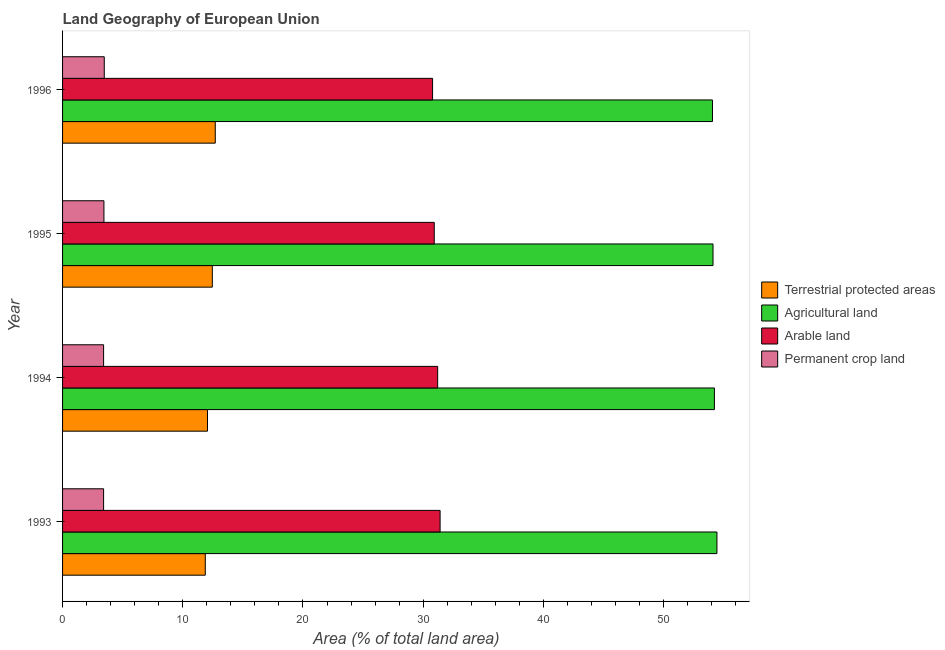Are the number of bars on each tick of the Y-axis equal?
Make the answer very short. Yes. How many bars are there on the 1st tick from the bottom?
Keep it short and to the point. 4. What is the label of the 2nd group of bars from the top?
Your answer should be compact. 1995. In how many cases, is the number of bars for a given year not equal to the number of legend labels?
Your answer should be compact. 0. What is the percentage of area under agricultural land in 1995?
Your answer should be very brief. 54.11. Across all years, what is the maximum percentage of area under agricultural land?
Make the answer very short. 54.44. Across all years, what is the minimum percentage of area under agricultural land?
Your response must be concise. 54.06. In which year was the percentage of land under terrestrial protection minimum?
Your answer should be very brief. 1993. What is the total percentage of area under permanent crop land in the graph?
Provide a succinct answer. 13.74. What is the difference between the percentage of area under agricultural land in 1994 and that in 1996?
Make the answer very short. 0.16. What is the difference between the percentage of area under permanent crop land in 1994 and the percentage of area under arable land in 1995?
Give a very brief answer. -27.51. What is the average percentage of area under arable land per year?
Provide a succinct answer. 31.08. In the year 1996, what is the difference between the percentage of area under permanent crop land and percentage of area under arable land?
Offer a very short reply. -27.31. Is the percentage of area under arable land in 1993 less than that in 1996?
Your answer should be very brief. No. Is the difference between the percentage of area under agricultural land in 1993 and 1996 greater than the difference between the percentage of land under terrestrial protection in 1993 and 1996?
Your response must be concise. Yes. What is the difference between the highest and the second highest percentage of land under terrestrial protection?
Your response must be concise. 0.25. What is the difference between the highest and the lowest percentage of land under terrestrial protection?
Give a very brief answer. 0.83. In how many years, is the percentage of area under permanent crop land greater than the average percentage of area under permanent crop land taken over all years?
Give a very brief answer. 2. Is it the case that in every year, the sum of the percentage of area under arable land and percentage of area under permanent crop land is greater than the sum of percentage of land under terrestrial protection and percentage of area under agricultural land?
Offer a very short reply. Yes. What does the 3rd bar from the top in 1994 represents?
Make the answer very short. Agricultural land. What does the 3rd bar from the bottom in 1996 represents?
Your response must be concise. Arable land. Is it the case that in every year, the sum of the percentage of land under terrestrial protection and percentage of area under agricultural land is greater than the percentage of area under arable land?
Offer a very short reply. Yes. Does the graph contain any zero values?
Ensure brevity in your answer.  No. Where does the legend appear in the graph?
Give a very brief answer. Center right. How many legend labels are there?
Your answer should be compact. 4. How are the legend labels stacked?
Provide a succinct answer. Vertical. What is the title of the graph?
Your response must be concise. Land Geography of European Union. Does "Belgium" appear as one of the legend labels in the graph?
Offer a terse response. No. What is the label or title of the X-axis?
Keep it short and to the point. Area (% of total land area). What is the Area (% of total land area) in Terrestrial protected areas in 1993?
Give a very brief answer. 11.87. What is the Area (% of total land area) of Agricultural land in 1993?
Provide a short and direct response. 54.44. What is the Area (% of total land area) in Arable land in 1993?
Offer a terse response. 31.41. What is the Area (% of total land area) of Permanent crop land in 1993?
Make the answer very short. 3.41. What is the Area (% of total land area) of Terrestrial protected areas in 1994?
Your answer should be compact. 12.06. What is the Area (% of total land area) of Agricultural land in 1994?
Provide a succinct answer. 54.23. What is the Area (% of total land area) of Arable land in 1994?
Provide a succinct answer. 31.2. What is the Area (% of total land area) of Permanent crop land in 1994?
Provide a succinct answer. 3.41. What is the Area (% of total land area) in Terrestrial protected areas in 1995?
Keep it short and to the point. 12.46. What is the Area (% of total land area) in Agricultural land in 1995?
Offer a very short reply. 54.11. What is the Area (% of total land area) of Arable land in 1995?
Your answer should be compact. 30.92. What is the Area (% of total land area) in Permanent crop land in 1995?
Provide a succinct answer. 3.44. What is the Area (% of total land area) in Terrestrial protected areas in 1996?
Your answer should be compact. 12.7. What is the Area (% of total land area) of Agricultural land in 1996?
Your answer should be compact. 54.06. What is the Area (% of total land area) in Arable land in 1996?
Offer a terse response. 30.78. What is the Area (% of total land area) of Permanent crop land in 1996?
Offer a terse response. 3.47. Across all years, what is the maximum Area (% of total land area) in Terrestrial protected areas?
Your answer should be compact. 12.7. Across all years, what is the maximum Area (% of total land area) in Agricultural land?
Your answer should be very brief. 54.44. Across all years, what is the maximum Area (% of total land area) in Arable land?
Keep it short and to the point. 31.41. Across all years, what is the maximum Area (% of total land area) of Permanent crop land?
Your answer should be very brief. 3.47. Across all years, what is the minimum Area (% of total land area) in Terrestrial protected areas?
Make the answer very short. 11.87. Across all years, what is the minimum Area (% of total land area) in Agricultural land?
Give a very brief answer. 54.06. Across all years, what is the minimum Area (% of total land area) in Arable land?
Provide a succinct answer. 30.78. Across all years, what is the minimum Area (% of total land area) of Permanent crop land?
Your answer should be compact. 3.41. What is the total Area (% of total land area) in Terrestrial protected areas in the graph?
Your answer should be very brief. 49.09. What is the total Area (% of total land area) of Agricultural land in the graph?
Offer a terse response. 216.84. What is the total Area (% of total land area) in Arable land in the graph?
Give a very brief answer. 124.31. What is the total Area (% of total land area) of Permanent crop land in the graph?
Your answer should be very brief. 13.74. What is the difference between the Area (% of total land area) in Terrestrial protected areas in 1993 and that in 1994?
Offer a terse response. -0.18. What is the difference between the Area (% of total land area) of Agricultural land in 1993 and that in 1994?
Provide a short and direct response. 0.21. What is the difference between the Area (% of total land area) in Arable land in 1993 and that in 1994?
Offer a terse response. 0.2. What is the difference between the Area (% of total land area) in Terrestrial protected areas in 1993 and that in 1995?
Your answer should be compact. -0.59. What is the difference between the Area (% of total land area) in Agricultural land in 1993 and that in 1995?
Keep it short and to the point. 0.33. What is the difference between the Area (% of total land area) in Arable land in 1993 and that in 1995?
Ensure brevity in your answer.  0.49. What is the difference between the Area (% of total land area) of Permanent crop land in 1993 and that in 1995?
Provide a short and direct response. -0.03. What is the difference between the Area (% of total land area) of Terrestrial protected areas in 1993 and that in 1996?
Your answer should be very brief. -0.83. What is the difference between the Area (% of total land area) of Agricultural land in 1993 and that in 1996?
Your answer should be very brief. 0.37. What is the difference between the Area (% of total land area) of Arable land in 1993 and that in 1996?
Give a very brief answer. 0.63. What is the difference between the Area (% of total land area) in Permanent crop land in 1993 and that in 1996?
Keep it short and to the point. -0.06. What is the difference between the Area (% of total land area) in Terrestrial protected areas in 1994 and that in 1995?
Give a very brief answer. -0.4. What is the difference between the Area (% of total land area) in Agricultural land in 1994 and that in 1995?
Your answer should be very brief. 0.12. What is the difference between the Area (% of total land area) in Arable land in 1994 and that in 1995?
Make the answer very short. 0.28. What is the difference between the Area (% of total land area) in Permanent crop land in 1994 and that in 1995?
Your response must be concise. -0.03. What is the difference between the Area (% of total land area) in Terrestrial protected areas in 1994 and that in 1996?
Provide a succinct answer. -0.65. What is the difference between the Area (% of total land area) of Agricultural land in 1994 and that in 1996?
Make the answer very short. 0.16. What is the difference between the Area (% of total land area) in Arable land in 1994 and that in 1996?
Give a very brief answer. 0.42. What is the difference between the Area (% of total land area) in Permanent crop land in 1994 and that in 1996?
Your answer should be very brief. -0.06. What is the difference between the Area (% of total land area) of Terrestrial protected areas in 1995 and that in 1996?
Offer a very short reply. -0.25. What is the difference between the Area (% of total land area) in Agricultural land in 1995 and that in 1996?
Your answer should be compact. 0.05. What is the difference between the Area (% of total land area) in Arable land in 1995 and that in 1996?
Provide a short and direct response. 0.14. What is the difference between the Area (% of total land area) in Permanent crop land in 1995 and that in 1996?
Ensure brevity in your answer.  -0.03. What is the difference between the Area (% of total land area) in Terrestrial protected areas in 1993 and the Area (% of total land area) in Agricultural land in 1994?
Make the answer very short. -42.35. What is the difference between the Area (% of total land area) of Terrestrial protected areas in 1993 and the Area (% of total land area) of Arable land in 1994?
Make the answer very short. -19.33. What is the difference between the Area (% of total land area) of Terrestrial protected areas in 1993 and the Area (% of total land area) of Permanent crop land in 1994?
Make the answer very short. 8.46. What is the difference between the Area (% of total land area) of Agricultural land in 1993 and the Area (% of total land area) of Arable land in 1994?
Provide a succinct answer. 23.23. What is the difference between the Area (% of total land area) in Agricultural land in 1993 and the Area (% of total land area) in Permanent crop land in 1994?
Give a very brief answer. 51.02. What is the difference between the Area (% of total land area) in Arable land in 1993 and the Area (% of total land area) in Permanent crop land in 1994?
Offer a very short reply. 27.99. What is the difference between the Area (% of total land area) in Terrestrial protected areas in 1993 and the Area (% of total land area) in Agricultural land in 1995?
Your answer should be compact. -42.24. What is the difference between the Area (% of total land area) in Terrestrial protected areas in 1993 and the Area (% of total land area) in Arable land in 1995?
Offer a terse response. -19.05. What is the difference between the Area (% of total land area) in Terrestrial protected areas in 1993 and the Area (% of total land area) in Permanent crop land in 1995?
Provide a succinct answer. 8.43. What is the difference between the Area (% of total land area) in Agricultural land in 1993 and the Area (% of total land area) in Arable land in 1995?
Provide a succinct answer. 23.52. What is the difference between the Area (% of total land area) in Agricultural land in 1993 and the Area (% of total land area) in Permanent crop land in 1995?
Your answer should be very brief. 51. What is the difference between the Area (% of total land area) of Arable land in 1993 and the Area (% of total land area) of Permanent crop land in 1995?
Provide a succinct answer. 27.97. What is the difference between the Area (% of total land area) in Terrestrial protected areas in 1993 and the Area (% of total land area) in Agricultural land in 1996?
Offer a very short reply. -42.19. What is the difference between the Area (% of total land area) in Terrestrial protected areas in 1993 and the Area (% of total land area) in Arable land in 1996?
Your answer should be compact. -18.91. What is the difference between the Area (% of total land area) in Terrestrial protected areas in 1993 and the Area (% of total land area) in Permanent crop land in 1996?
Ensure brevity in your answer.  8.4. What is the difference between the Area (% of total land area) in Agricultural land in 1993 and the Area (% of total land area) in Arable land in 1996?
Keep it short and to the point. 23.66. What is the difference between the Area (% of total land area) of Agricultural land in 1993 and the Area (% of total land area) of Permanent crop land in 1996?
Your answer should be compact. 50.97. What is the difference between the Area (% of total land area) in Arable land in 1993 and the Area (% of total land area) in Permanent crop land in 1996?
Ensure brevity in your answer.  27.94. What is the difference between the Area (% of total land area) of Terrestrial protected areas in 1994 and the Area (% of total land area) of Agricultural land in 1995?
Offer a terse response. -42.05. What is the difference between the Area (% of total land area) of Terrestrial protected areas in 1994 and the Area (% of total land area) of Arable land in 1995?
Your answer should be compact. -18.86. What is the difference between the Area (% of total land area) of Terrestrial protected areas in 1994 and the Area (% of total land area) of Permanent crop land in 1995?
Provide a short and direct response. 8.62. What is the difference between the Area (% of total land area) of Agricultural land in 1994 and the Area (% of total land area) of Arable land in 1995?
Ensure brevity in your answer.  23.31. What is the difference between the Area (% of total land area) in Agricultural land in 1994 and the Area (% of total land area) in Permanent crop land in 1995?
Provide a short and direct response. 50.78. What is the difference between the Area (% of total land area) of Arable land in 1994 and the Area (% of total land area) of Permanent crop land in 1995?
Make the answer very short. 27.76. What is the difference between the Area (% of total land area) of Terrestrial protected areas in 1994 and the Area (% of total land area) of Agricultural land in 1996?
Make the answer very short. -42.01. What is the difference between the Area (% of total land area) in Terrestrial protected areas in 1994 and the Area (% of total land area) in Arable land in 1996?
Provide a succinct answer. -18.72. What is the difference between the Area (% of total land area) of Terrestrial protected areas in 1994 and the Area (% of total land area) of Permanent crop land in 1996?
Keep it short and to the point. 8.59. What is the difference between the Area (% of total land area) of Agricultural land in 1994 and the Area (% of total land area) of Arable land in 1996?
Your answer should be compact. 23.45. What is the difference between the Area (% of total land area) in Agricultural land in 1994 and the Area (% of total land area) in Permanent crop land in 1996?
Your response must be concise. 50.76. What is the difference between the Area (% of total land area) in Arable land in 1994 and the Area (% of total land area) in Permanent crop land in 1996?
Provide a succinct answer. 27.74. What is the difference between the Area (% of total land area) of Terrestrial protected areas in 1995 and the Area (% of total land area) of Agricultural land in 1996?
Make the answer very short. -41.61. What is the difference between the Area (% of total land area) in Terrestrial protected areas in 1995 and the Area (% of total land area) in Arable land in 1996?
Offer a terse response. -18.32. What is the difference between the Area (% of total land area) in Terrestrial protected areas in 1995 and the Area (% of total land area) in Permanent crop land in 1996?
Offer a very short reply. 8.99. What is the difference between the Area (% of total land area) in Agricultural land in 1995 and the Area (% of total land area) in Arable land in 1996?
Your answer should be very brief. 23.33. What is the difference between the Area (% of total land area) in Agricultural land in 1995 and the Area (% of total land area) in Permanent crop land in 1996?
Provide a succinct answer. 50.64. What is the difference between the Area (% of total land area) of Arable land in 1995 and the Area (% of total land area) of Permanent crop land in 1996?
Make the answer very short. 27.45. What is the average Area (% of total land area) in Terrestrial protected areas per year?
Your response must be concise. 12.27. What is the average Area (% of total land area) of Agricultural land per year?
Your answer should be compact. 54.21. What is the average Area (% of total land area) in Arable land per year?
Your response must be concise. 31.08. What is the average Area (% of total land area) of Permanent crop land per year?
Your response must be concise. 3.43. In the year 1993, what is the difference between the Area (% of total land area) of Terrestrial protected areas and Area (% of total land area) of Agricultural land?
Offer a terse response. -42.56. In the year 1993, what is the difference between the Area (% of total land area) of Terrestrial protected areas and Area (% of total land area) of Arable land?
Your response must be concise. -19.53. In the year 1993, what is the difference between the Area (% of total land area) in Terrestrial protected areas and Area (% of total land area) in Permanent crop land?
Your answer should be very brief. 8.46. In the year 1993, what is the difference between the Area (% of total land area) in Agricultural land and Area (% of total land area) in Arable land?
Make the answer very short. 23.03. In the year 1993, what is the difference between the Area (% of total land area) of Agricultural land and Area (% of total land area) of Permanent crop land?
Ensure brevity in your answer.  51.02. In the year 1993, what is the difference between the Area (% of total land area) in Arable land and Area (% of total land area) in Permanent crop land?
Provide a succinct answer. 27.99. In the year 1994, what is the difference between the Area (% of total land area) in Terrestrial protected areas and Area (% of total land area) in Agricultural land?
Offer a very short reply. -42.17. In the year 1994, what is the difference between the Area (% of total land area) of Terrestrial protected areas and Area (% of total land area) of Arable land?
Keep it short and to the point. -19.15. In the year 1994, what is the difference between the Area (% of total land area) of Terrestrial protected areas and Area (% of total land area) of Permanent crop land?
Give a very brief answer. 8.64. In the year 1994, what is the difference between the Area (% of total land area) of Agricultural land and Area (% of total land area) of Arable land?
Your answer should be very brief. 23.02. In the year 1994, what is the difference between the Area (% of total land area) in Agricultural land and Area (% of total land area) in Permanent crop land?
Give a very brief answer. 50.81. In the year 1994, what is the difference between the Area (% of total land area) of Arable land and Area (% of total land area) of Permanent crop land?
Make the answer very short. 27.79. In the year 1995, what is the difference between the Area (% of total land area) in Terrestrial protected areas and Area (% of total land area) in Agricultural land?
Ensure brevity in your answer.  -41.65. In the year 1995, what is the difference between the Area (% of total land area) in Terrestrial protected areas and Area (% of total land area) in Arable land?
Offer a terse response. -18.46. In the year 1995, what is the difference between the Area (% of total land area) in Terrestrial protected areas and Area (% of total land area) in Permanent crop land?
Give a very brief answer. 9.02. In the year 1995, what is the difference between the Area (% of total land area) of Agricultural land and Area (% of total land area) of Arable land?
Make the answer very short. 23.19. In the year 1995, what is the difference between the Area (% of total land area) of Agricultural land and Area (% of total land area) of Permanent crop land?
Your answer should be compact. 50.67. In the year 1995, what is the difference between the Area (% of total land area) of Arable land and Area (% of total land area) of Permanent crop land?
Provide a succinct answer. 27.48. In the year 1996, what is the difference between the Area (% of total land area) of Terrestrial protected areas and Area (% of total land area) of Agricultural land?
Your answer should be compact. -41.36. In the year 1996, what is the difference between the Area (% of total land area) of Terrestrial protected areas and Area (% of total land area) of Arable land?
Make the answer very short. -18.08. In the year 1996, what is the difference between the Area (% of total land area) in Terrestrial protected areas and Area (% of total land area) in Permanent crop land?
Keep it short and to the point. 9.24. In the year 1996, what is the difference between the Area (% of total land area) of Agricultural land and Area (% of total land area) of Arable land?
Provide a succinct answer. 23.28. In the year 1996, what is the difference between the Area (% of total land area) of Agricultural land and Area (% of total land area) of Permanent crop land?
Offer a very short reply. 50.6. In the year 1996, what is the difference between the Area (% of total land area) in Arable land and Area (% of total land area) in Permanent crop land?
Your answer should be very brief. 27.31. What is the ratio of the Area (% of total land area) of Terrestrial protected areas in 1993 to that in 1994?
Your response must be concise. 0.98. What is the ratio of the Area (% of total land area) of Terrestrial protected areas in 1993 to that in 1995?
Your answer should be very brief. 0.95. What is the ratio of the Area (% of total land area) of Arable land in 1993 to that in 1995?
Your answer should be very brief. 1.02. What is the ratio of the Area (% of total land area) in Permanent crop land in 1993 to that in 1995?
Your answer should be very brief. 0.99. What is the ratio of the Area (% of total land area) of Terrestrial protected areas in 1993 to that in 1996?
Your response must be concise. 0.93. What is the ratio of the Area (% of total land area) in Arable land in 1993 to that in 1996?
Your answer should be compact. 1.02. What is the ratio of the Area (% of total land area) of Permanent crop land in 1993 to that in 1996?
Provide a short and direct response. 0.98. What is the ratio of the Area (% of total land area) of Terrestrial protected areas in 1994 to that in 1995?
Offer a terse response. 0.97. What is the ratio of the Area (% of total land area) in Agricultural land in 1994 to that in 1995?
Make the answer very short. 1. What is the ratio of the Area (% of total land area) of Arable land in 1994 to that in 1995?
Ensure brevity in your answer.  1.01. What is the ratio of the Area (% of total land area) in Terrestrial protected areas in 1994 to that in 1996?
Ensure brevity in your answer.  0.95. What is the ratio of the Area (% of total land area) in Arable land in 1994 to that in 1996?
Your answer should be very brief. 1.01. What is the ratio of the Area (% of total land area) in Permanent crop land in 1994 to that in 1996?
Provide a succinct answer. 0.98. What is the ratio of the Area (% of total land area) of Terrestrial protected areas in 1995 to that in 1996?
Offer a terse response. 0.98. What is the ratio of the Area (% of total land area) in Arable land in 1995 to that in 1996?
Your response must be concise. 1. What is the difference between the highest and the second highest Area (% of total land area) in Terrestrial protected areas?
Make the answer very short. 0.25. What is the difference between the highest and the second highest Area (% of total land area) in Agricultural land?
Ensure brevity in your answer.  0.21. What is the difference between the highest and the second highest Area (% of total land area) in Arable land?
Ensure brevity in your answer.  0.2. What is the difference between the highest and the second highest Area (% of total land area) in Permanent crop land?
Give a very brief answer. 0.03. What is the difference between the highest and the lowest Area (% of total land area) of Terrestrial protected areas?
Give a very brief answer. 0.83. What is the difference between the highest and the lowest Area (% of total land area) in Agricultural land?
Give a very brief answer. 0.37. What is the difference between the highest and the lowest Area (% of total land area) in Arable land?
Your answer should be compact. 0.63. What is the difference between the highest and the lowest Area (% of total land area) of Permanent crop land?
Provide a succinct answer. 0.06. 